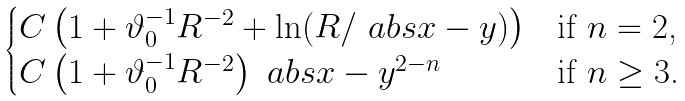<formula> <loc_0><loc_0><loc_500><loc_500>\begin{cases} C \left ( 1 + \vartheta _ { 0 } ^ { - 1 } R ^ { - 2 } + \ln ( R / \ a b s { x - y } ) \right ) & \text {if $n=2$,} \\ C \left ( 1 + \vartheta _ { 0 } ^ { - 1 } R ^ { - 2 } \right ) \ a b s { x - y } ^ { 2 - n } & \text {if $n\geq 3$.} \end{cases}</formula> 